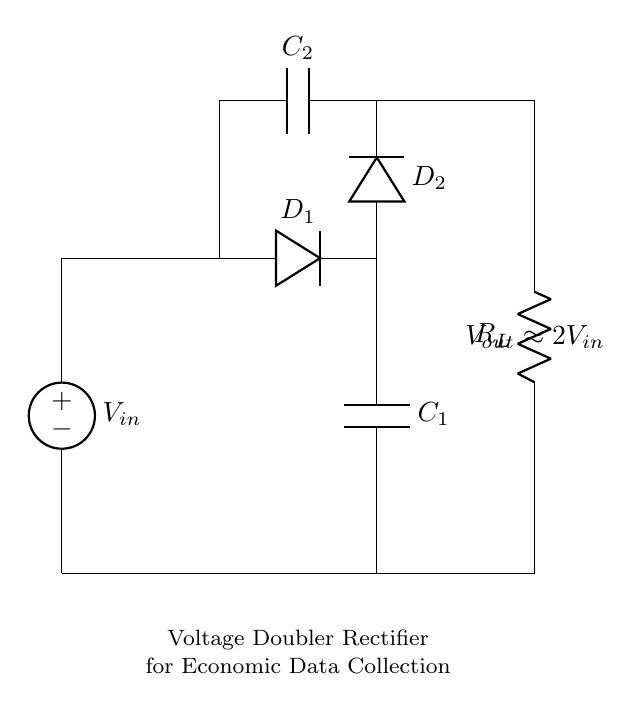What is the input voltage of this circuit? The input voltage is denoted as V subscript in, which is the source voltage supplied to the circuit.
Answer: V in What type of capacitors are used in the circuit? The circuit employs two capacitors, C subscript one and C subscript two, indicated in the diagram.
Answer: Capacitors What is the expected output voltage of this circuit? The output voltage is indicated as approximately two times the input voltage, represented as V subscript out approximately equals 2 V subscript in.
Answer: 2 V in Which components are responsible for rectification in this circuit? The rectification is achieved by two diodes, D subscript one and D subscript two, which are marked on the circuit diagram.
Answer: Diodes How many resistors are present in the circuit? There is one resistor in the circuit, labeled R subscript L in the diagram.
Answer: One resistor What is the role of C subscript one in this circuit? C subscript one acts as a filter capacitor that smooths the output voltage after the rectification process, serving to reduce voltage ripple.
Answer: Filtering Why is the output voltage approximately double the input voltage? The configuration of the voltage doubler rectifier circuit allows it to effectively charge the capacitors in such a way that the output voltage reaches approximately double that of the input voltage, due to the sequential charging through the diodes during different phases.
Answer: Voltage doubling 